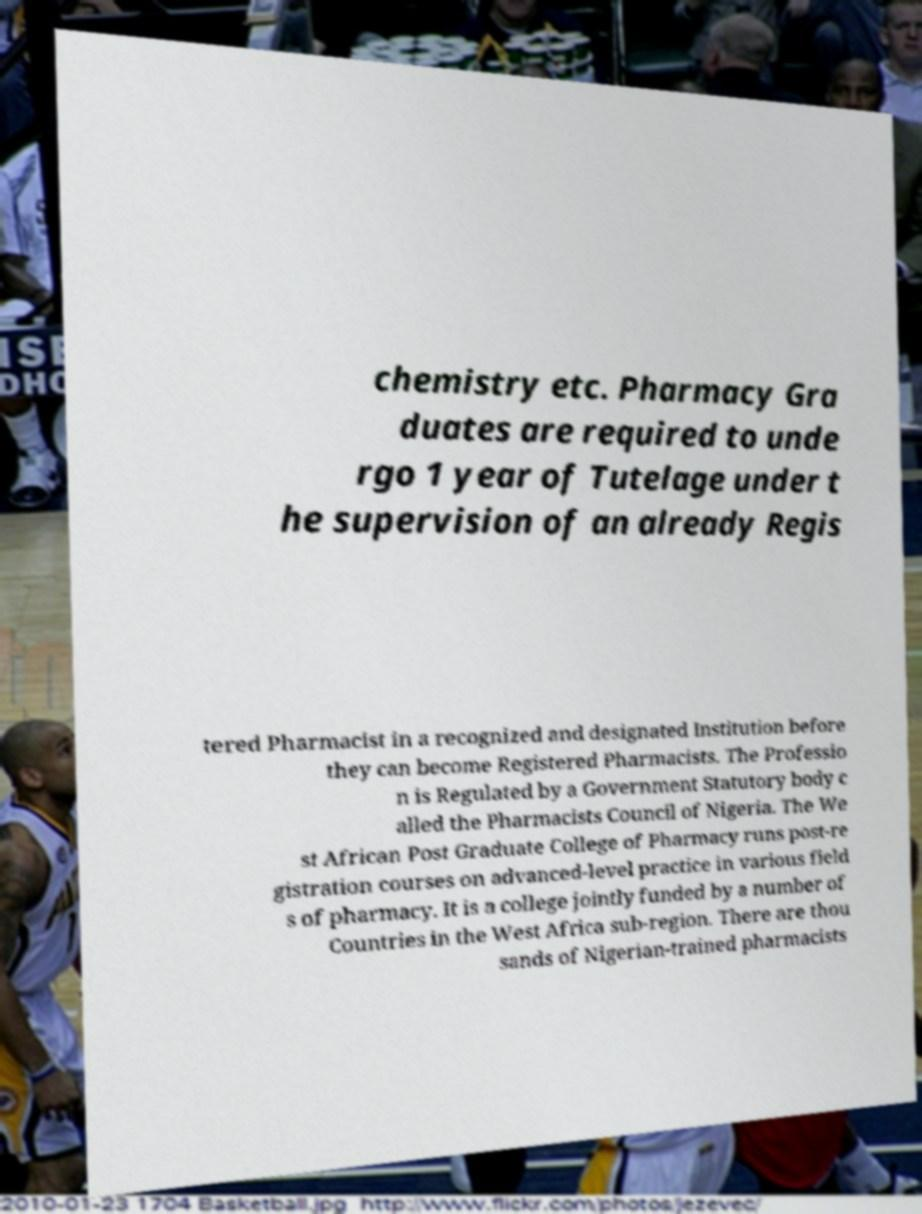Can you accurately transcribe the text from the provided image for me? chemistry etc. Pharmacy Gra duates are required to unde rgo 1 year of Tutelage under t he supervision of an already Regis tered Pharmacist in a recognized and designated Institution before they can become Registered Pharmacists. The Professio n is Regulated by a Government Statutory body c alled the Pharmacists Council of Nigeria. The We st African Post Graduate College of Pharmacy runs post-re gistration courses on advanced-level practice in various field s of pharmacy. It is a college jointly funded by a number of Countries in the West Africa sub-region. There are thou sands of Nigerian-trained pharmacists 